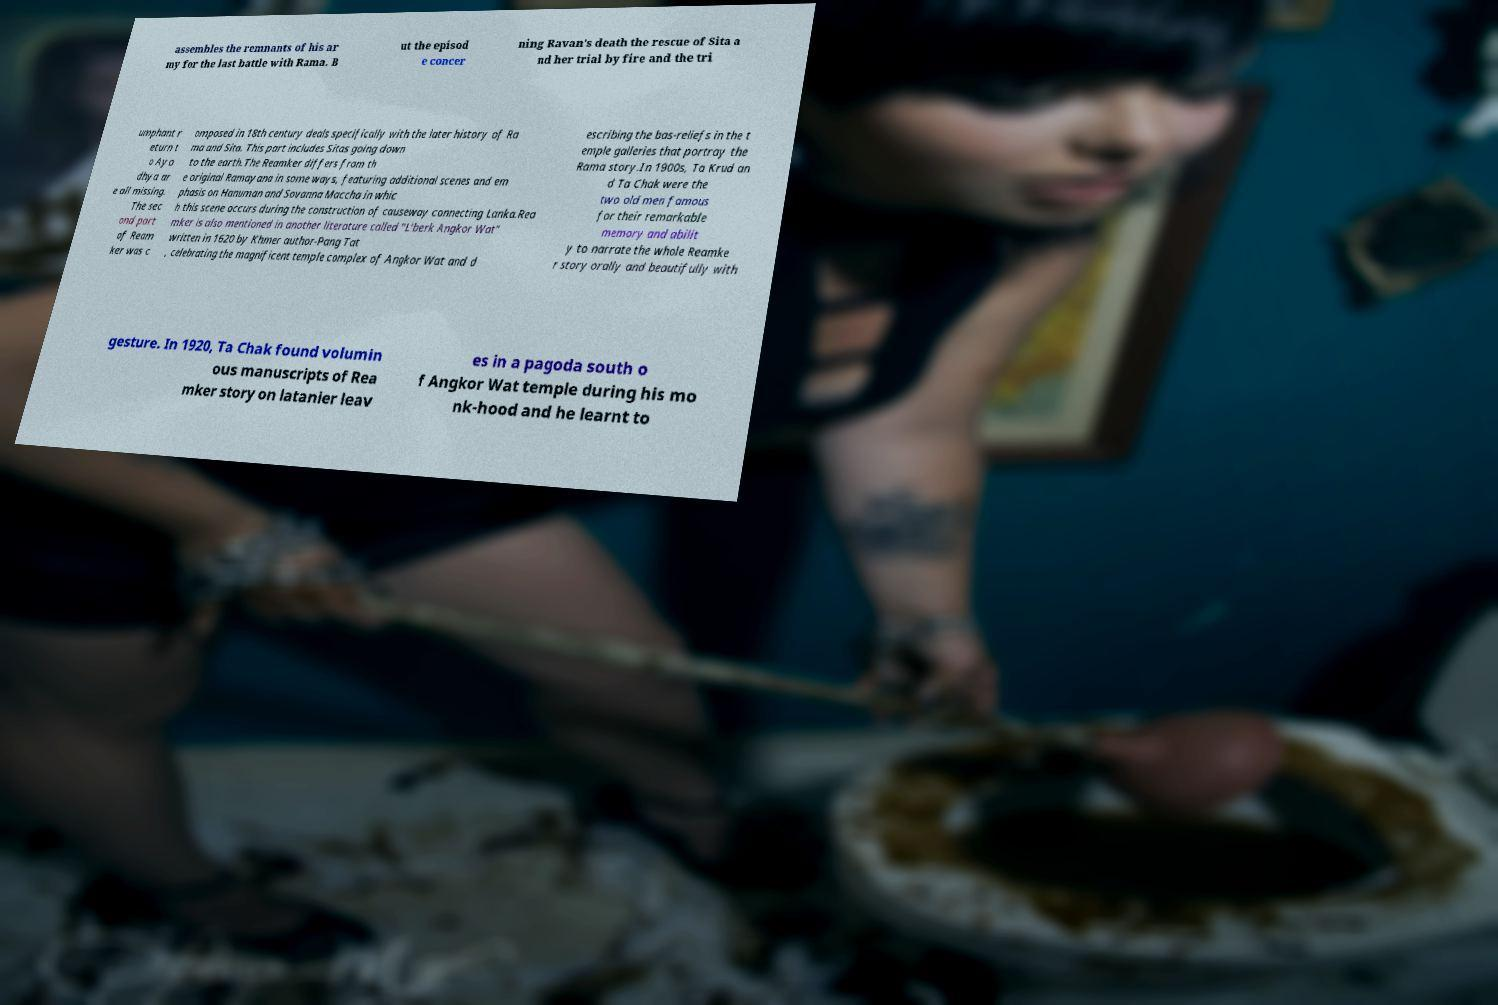Please read and relay the text visible in this image. What does it say? assembles the remnants of his ar my for the last battle with Rama. B ut the episod e concer ning Ravan's death the rescue of Sita a nd her trial by fire and the tri umphant r eturn t o Ayo dhya ar e all missing. The sec ond part of Ream ker was c omposed in 18th century deals specifically with the later history of Ra ma and Sita. This part includes Sitas going down to the earth.The Reamker differs from th e original Ramayana in some ways, featuring additional scenes and em phasis on Hanuman and Sovanna Maccha in whic h this scene occurs during the construction of causeway connecting Lanka.Rea mker is also mentioned in another literature called "L'berk Angkor Wat" written in 1620 by Khmer author-Pang Tat , celebrating the magnificent temple complex of Angkor Wat and d escribing the bas-reliefs in the t emple galleries that portray the Rama story.In 1900s, Ta Krud an d Ta Chak were the two old men famous for their remarkable memory and abilit y to narrate the whole Reamke r story orally and beautifully with gesture. In 1920, Ta Chak found volumin ous manuscripts of Rea mker story on latanier leav es in a pagoda south o f Angkor Wat temple during his mo nk-hood and he learnt to 